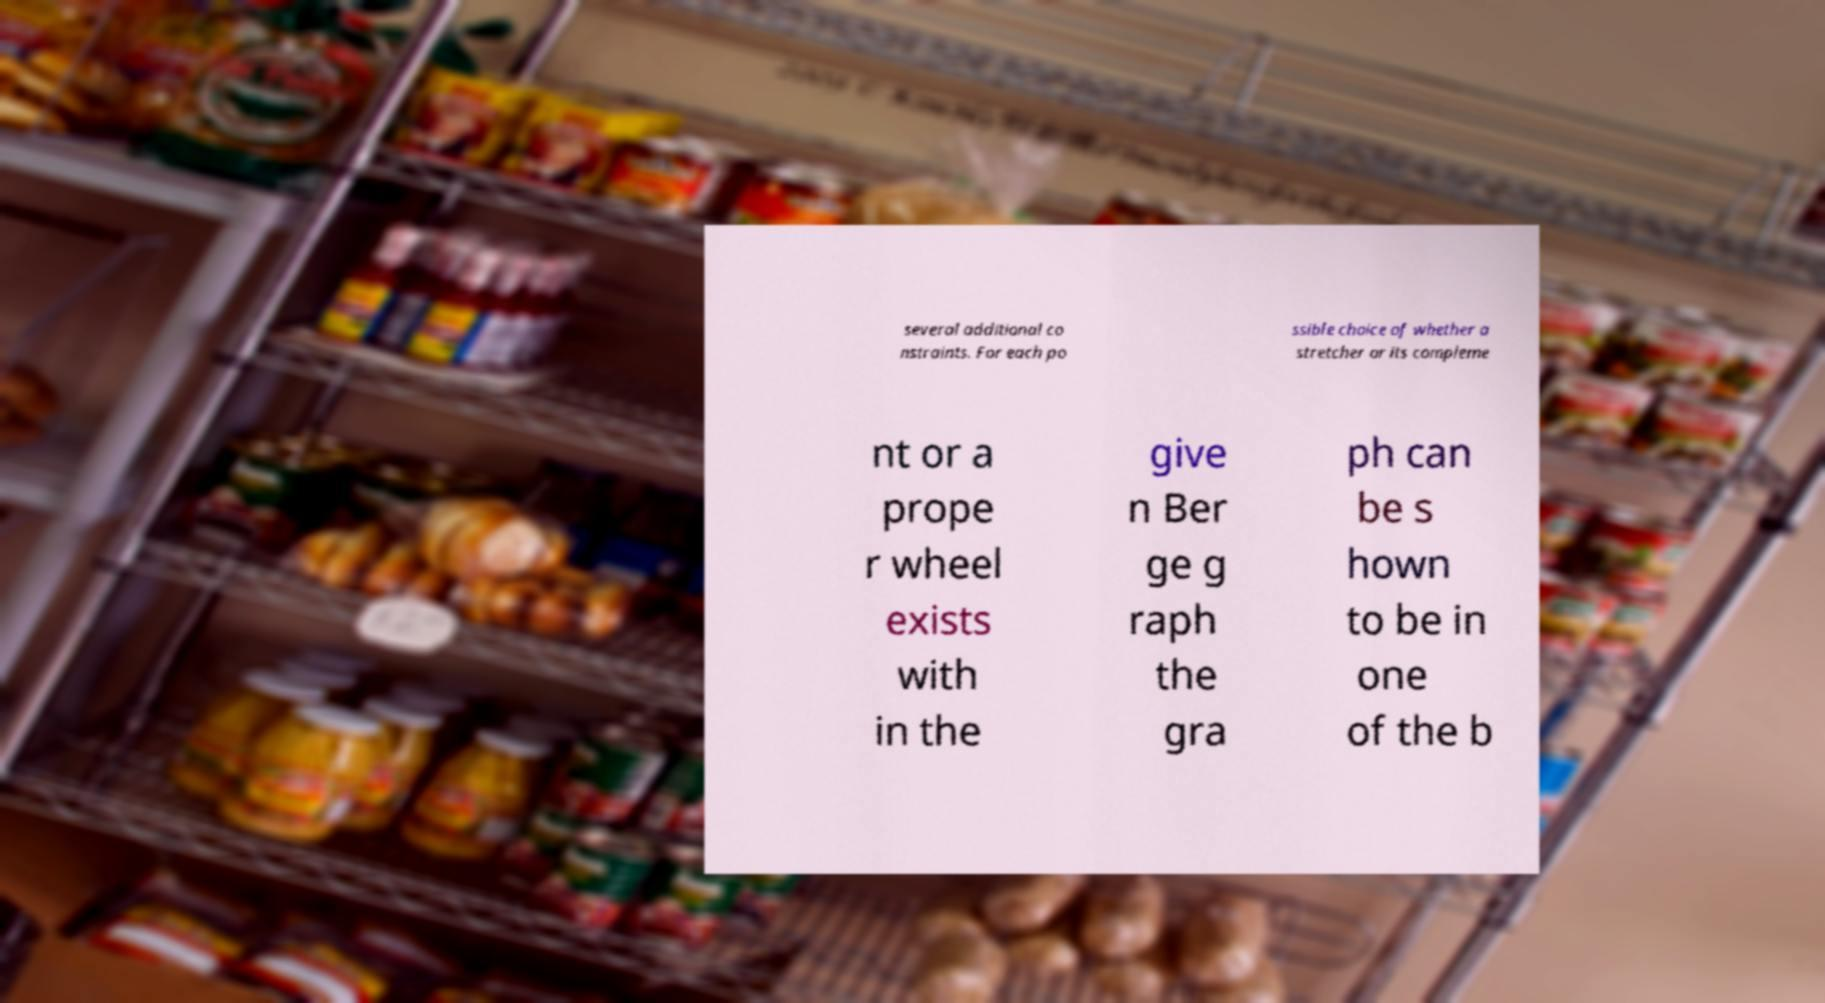I need the written content from this picture converted into text. Can you do that? several additional co nstraints. For each po ssible choice of whether a stretcher or its compleme nt or a prope r wheel exists with in the give n Ber ge g raph the gra ph can be s hown to be in one of the b 